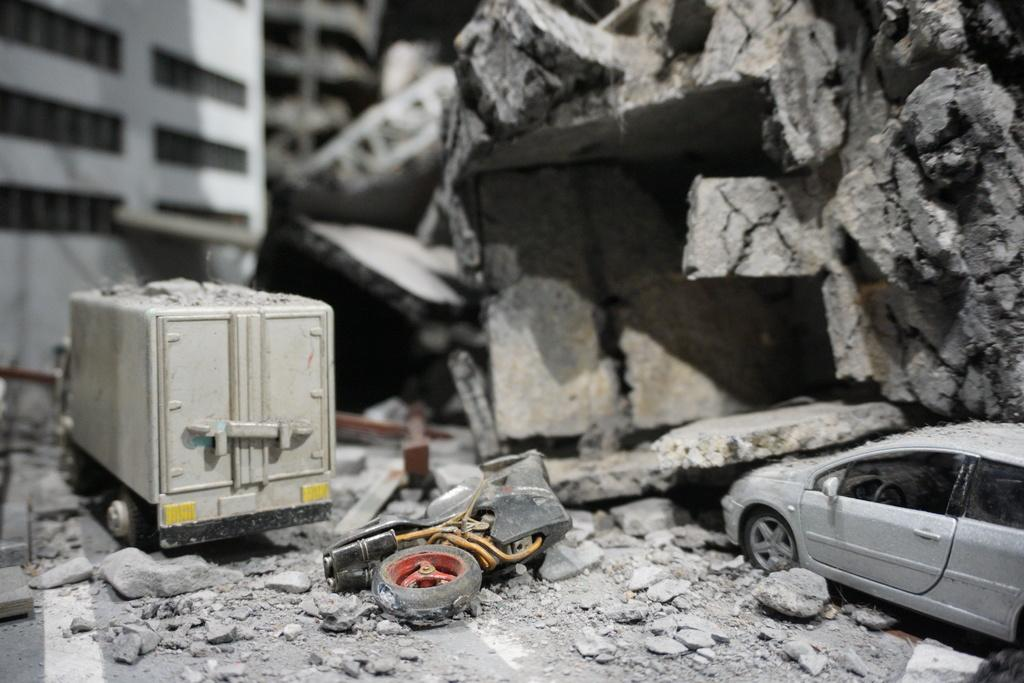How many toys are on the floor in the image? There are three toys on the floor in the image. What can be observed about the cleanliness of the floor? There is a lot of dust around the floor in the image. What is located on the right side of the image? Huge rocks are on the right side of the image. Can you describe the background of the image? The background of the image is blurry. What type of quarter is visible in the image? There is no quarter present in the image. Can you describe the attack happening in the image? There is no attack depicted in the image; it features toys, dust, rocks, and a blurry background. 